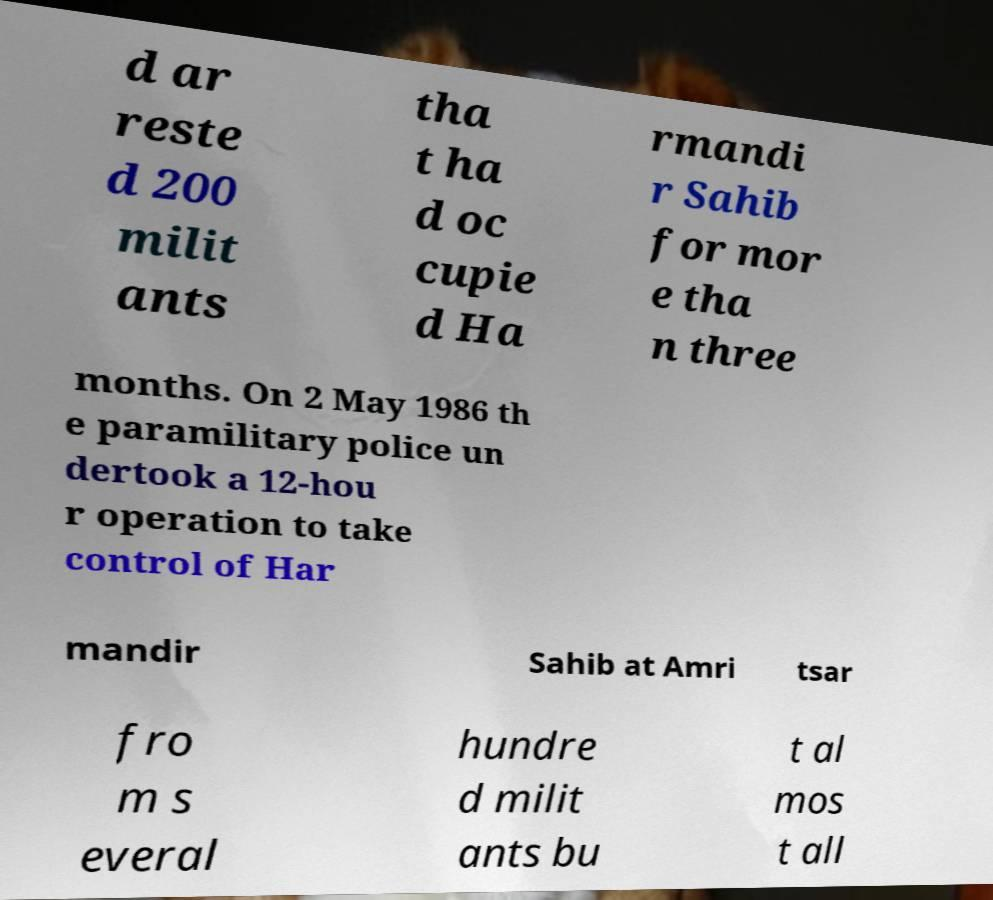Can you accurately transcribe the text from the provided image for me? d ar reste d 200 milit ants tha t ha d oc cupie d Ha rmandi r Sahib for mor e tha n three months. On 2 May 1986 th e paramilitary police un dertook a 12-hou r operation to take control of Har mandir Sahib at Amri tsar fro m s everal hundre d milit ants bu t al mos t all 